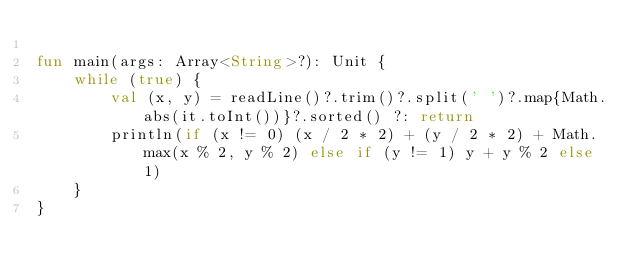<code> <loc_0><loc_0><loc_500><loc_500><_Kotlin_>
fun main(args: Array<String>?): Unit {
    while (true) {
        val (x, y) = readLine()?.trim()?.split(' ')?.map{Math.abs(it.toInt())}?.sorted() ?: return
        println(if (x != 0) (x / 2 * 2) + (y / 2 * 2) + Math.max(x % 2, y % 2) else if (y != 1) y + y % 2 else 1)
    }
}
</code> 